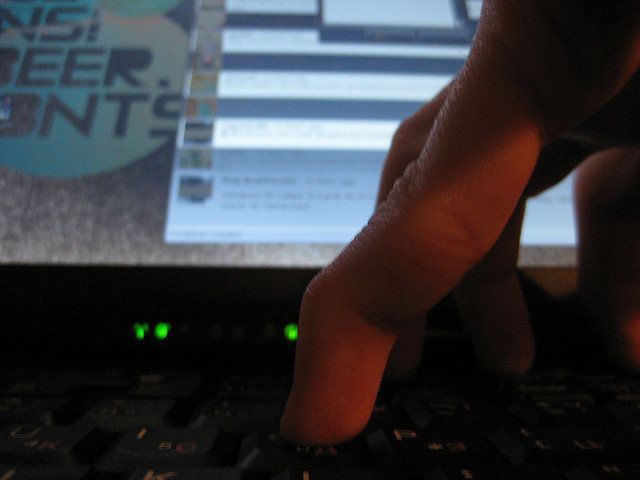Read all the text in this image. NSI BEER NTS 